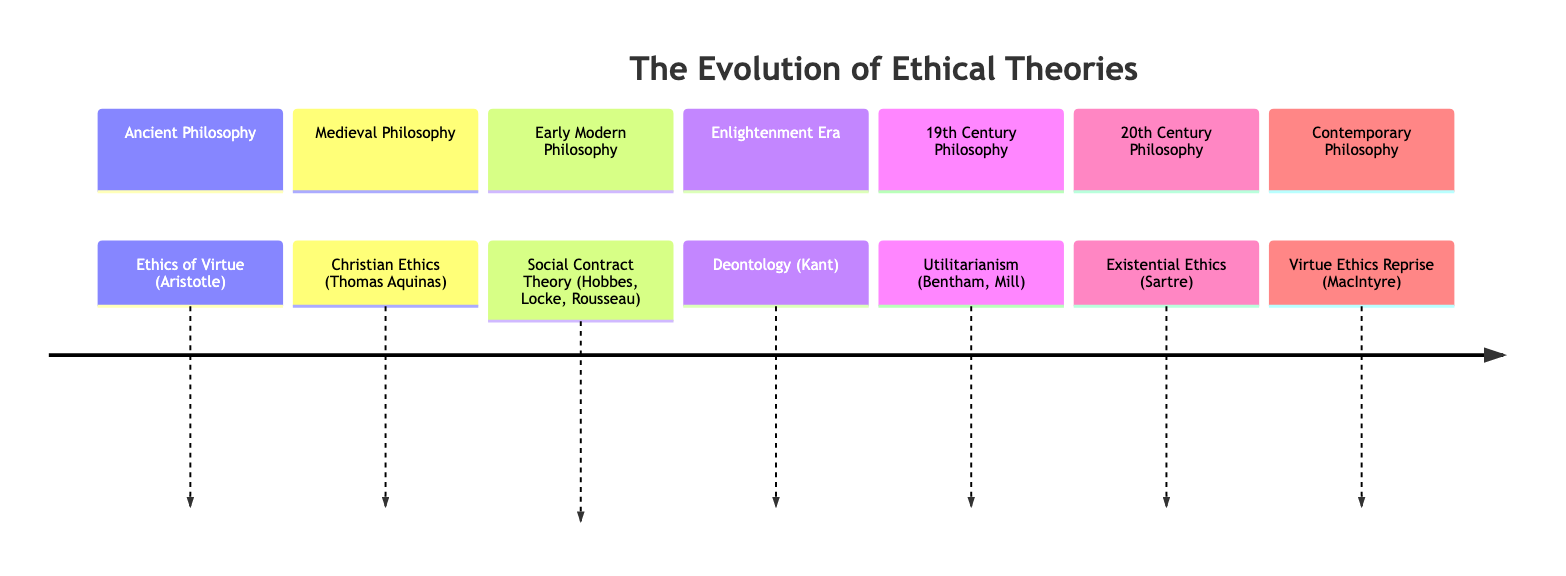What is the first ethical theory mentioned in the timeline? The timeline starts with "Ethics of Virtue (Aristotle)" as part of Ancient Philosophy. This is the first entry in the diagram, marking the beginning of the evolution of ethical theories.
Answer: Ethics of Virtue (Aristotle) How many distinct sections are in the diagram? The diagram contains seven distinct sections, each representing a different era or philosophical approach to ethics. These sections are carefully labeled and structured within the timeline.
Answer: 7 Which ethical theory is associated with the Enlightenment Era? According to the diagram, the Enlightenment Era is associated with "Deontology (Kant)." This entry signifies a shift in ethical theories toward duty-based ethics during this period.
Answer: Deontology (Kant) Who is credited with the development of Utilitarianism? The diagram attributes the development of Utilitarianism to "Bentham" and "Mill," listing them together to highlight their contributions to this ethical theory.
Answer: Bentham, Mill What philosophical era follows Early Modern Philosophy in the timeline? Following Early Modern Philosophy, which includes the Social Contract Theory, the next era depicted in the timeline is the "Enlightenment Era." This indicates a chronological progression in thoughts on ethics.
Answer: Enlightenment Era How does the contemporary philosophical approach differ from Ancient Philosophy? The diagram shows that the contemporary approach, "Virtue Ethics Reprise (MacIntyre)," is a return to virtue ethics, while Ancient Philosophy originally laid the groundwork for this foundation. This contrast highlights how ethical theories evolve over time.
Answer: Virtue Ethics Reprise (MacIntyre) What does Existential Ethics focus on according to 20th Century Philosophy? The timeline indicates that Existential Ethics, represented by "Sartre," focuses on individual existence and the meaning of personal choices. This reflects a significant philosophical shift from collective to individual perspectives.
Answer: Individual existence Which ethical theory represents a significant development in Medieval Philosophy? The timeline demonstrates that "Christian Ethics (Thomas Aquinas)" represents a significant development in Medieval Philosophy, emphasizing the influence of religious thought on ethical theories during this period.
Answer: Christian Ethics (Thomas Aquinas) 